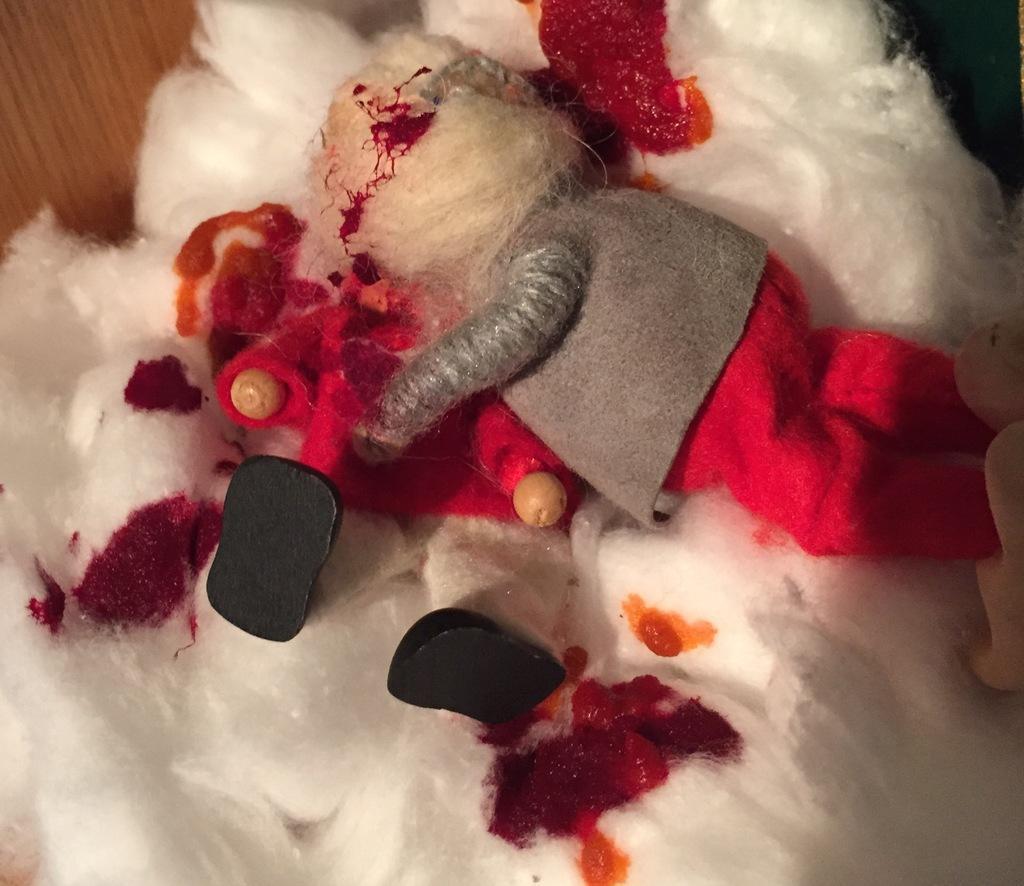Could you give a brief overview of what you see in this image? In the picture we can see a wooden plank on it, we can see cotton and on it we can see a doll and on the cotton we can see some red color marks. 